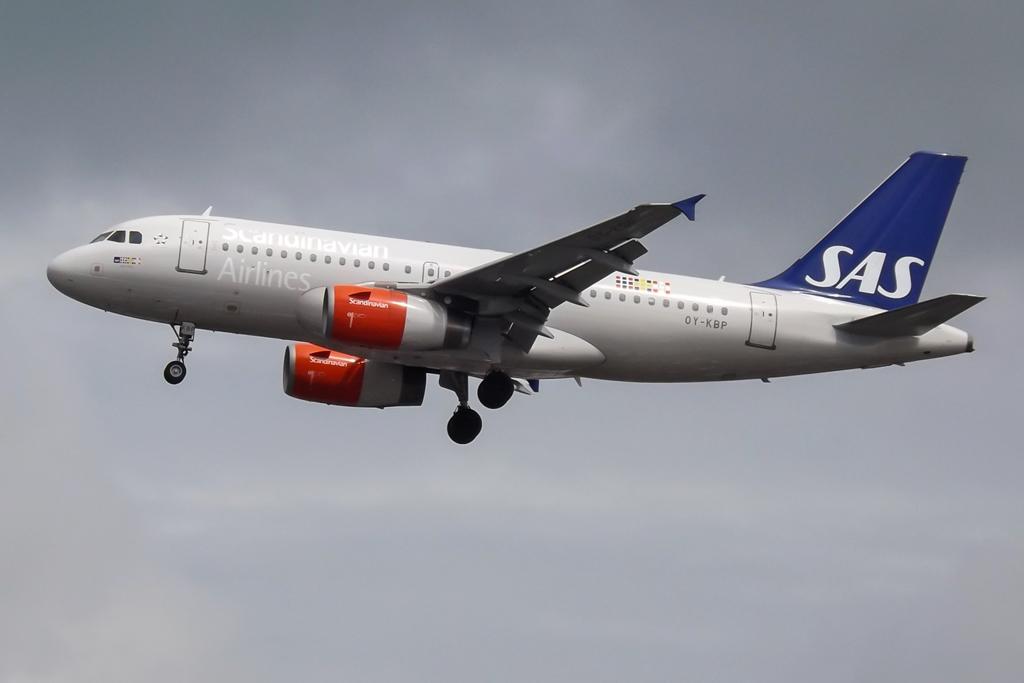What are the initials of this airline?
Offer a very short reply. Sas. 